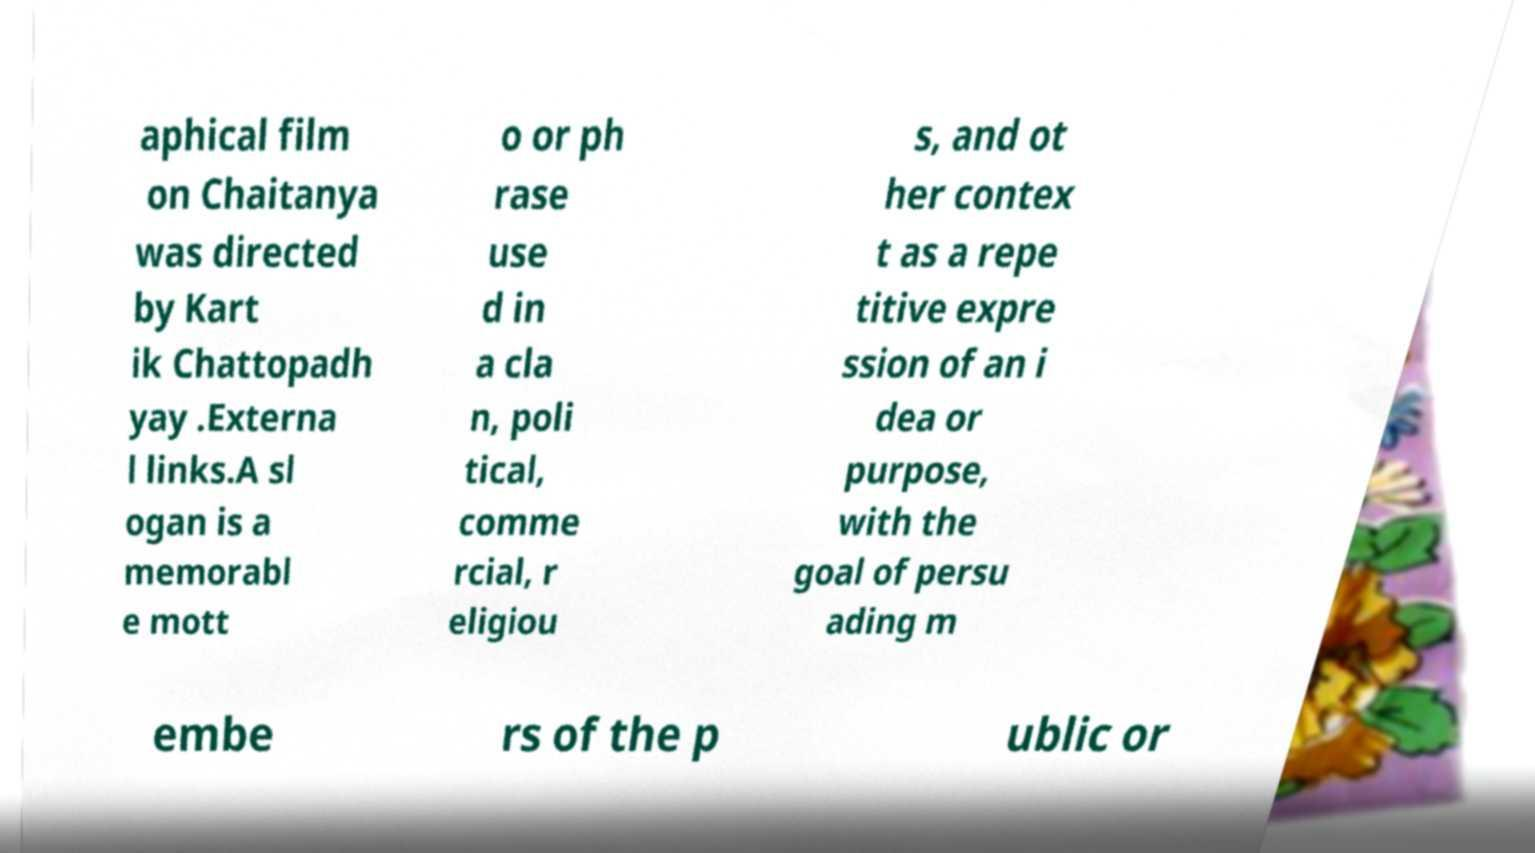Can you accurately transcribe the text from the provided image for me? aphical film on Chaitanya was directed by Kart ik Chattopadh yay .Externa l links.A sl ogan is a memorabl e mott o or ph rase use d in a cla n, poli tical, comme rcial, r eligiou s, and ot her contex t as a repe titive expre ssion of an i dea or purpose, with the goal of persu ading m embe rs of the p ublic or 